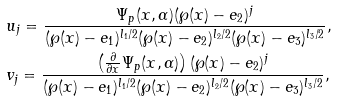<formula> <loc_0><loc_0><loc_500><loc_500>& u _ { j } = \frac { \Psi _ { p } ( x , \alpha ) ( \wp ( x ) - e _ { 2 } ) ^ { j } } { ( \wp ( x ) - e _ { 1 } ) ^ { l _ { 1 } / 2 } ( \wp ( x ) - e _ { 2 } ) ^ { l _ { 2 } / 2 } ( \wp ( x ) - e _ { 3 } ) ^ { l _ { 3 } / 2 } } , \\ & v _ { j } = \frac { \left ( \frac { \partial } { \partial x } \Psi _ { p } ( x , \alpha ) \right ) ( \wp ( x ) - e _ { 2 } ) ^ { j } } { ( \wp ( x ) - e _ { 1 } ) ^ { l _ { 1 } / 2 } ( \wp ( x ) - e _ { 2 } ) ^ { l _ { 2 } / 2 } ( \wp ( x ) - e _ { 3 } ) ^ { l _ { 3 } / 2 } } ,</formula> 